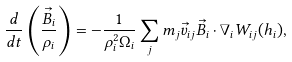<formula> <loc_0><loc_0><loc_500><loc_500>\frac { d } { d t } \left ( \frac { \vec { B } _ { i } } { \rho _ { i } } \right ) = - \frac { 1 } { \rho _ { i } ^ { 2 } \Omega _ { i } } \sum _ { j } m _ { j } \vec { v } _ { i j } \vec { B } _ { i } \cdot \nabla _ { i } W _ { i j } ( h _ { i } ) ,</formula> 